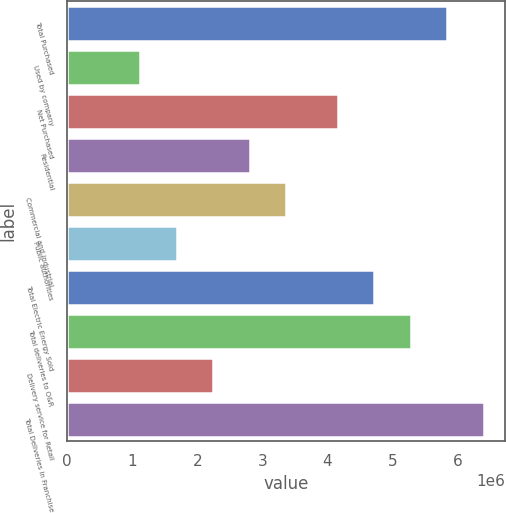Convert chart. <chart><loc_0><loc_0><loc_500><loc_500><bar_chart><fcel>Total Purchased<fcel>Used by company<fcel>Net Purchased<fcel>Residential<fcel>Commercial and industrial<fcel>Public authorities<fcel>Total Electric Energy Sold<fcel>Total deliveries to O&R<fcel>Delivery service for Retail<fcel>Total Deliveries In Franchise<nl><fcel>5.8414e+06<fcel>1.1225e+06<fcel>4.15767e+06<fcel>2.80624e+06<fcel>3.36748e+06<fcel>1.68375e+06<fcel>4.71891e+06<fcel>5.28016e+06<fcel>2.24499e+06<fcel>6.40265e+06<nl></chart> 